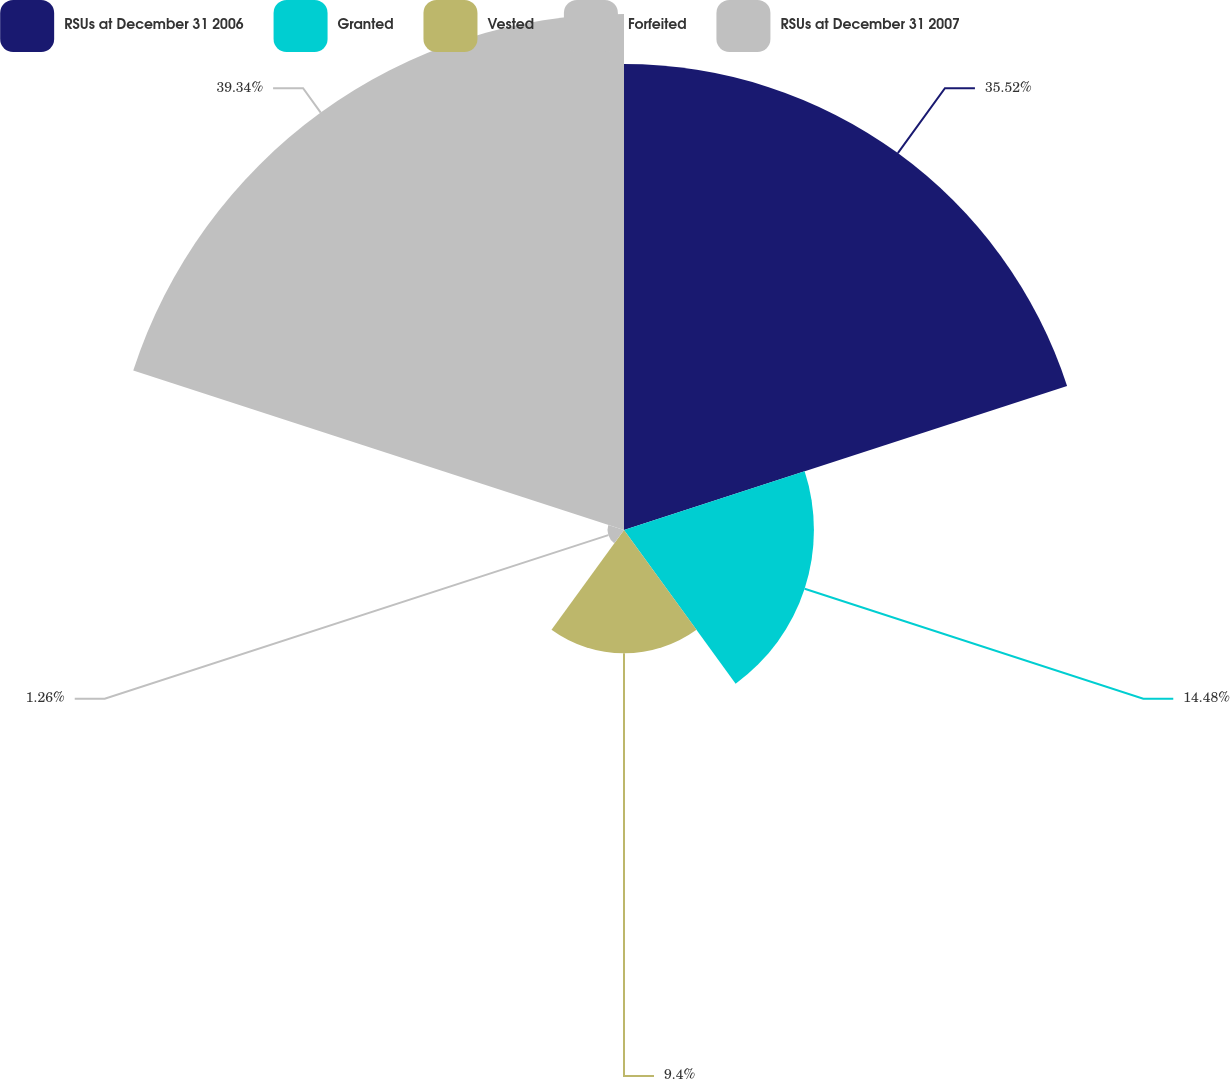Convert chart. <chart><loc_0><loc_0><loc_500><loc_500><pie_chart><fcel>RSUs at December 31 2006<fcel>Granted<fcel>Vested<fcel>Forfeited<fcel>RSUs at December 31 2007<nl><fcel>35.52%<fcel>14.48%<fcel>9.4%<fcel>1.26%<fcel>39.34%<nl></chart> 